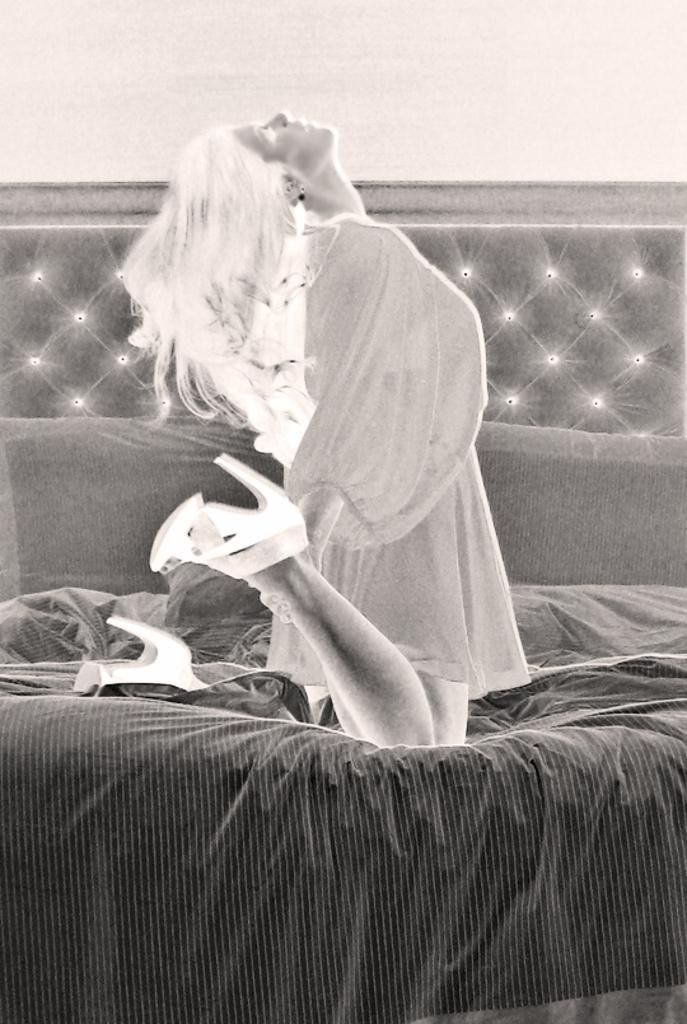What type of image is being displayed? The image is a negative image. What is the girl in the image doing? The girl is sitting on the bed. What can be seen in the background of the image? There is a wall in the background of the image. Can you tell me how many beasts are swimming in the river in the image? There is no river or beast present in the image; it features a girl sitting on a bed in a negative image. 